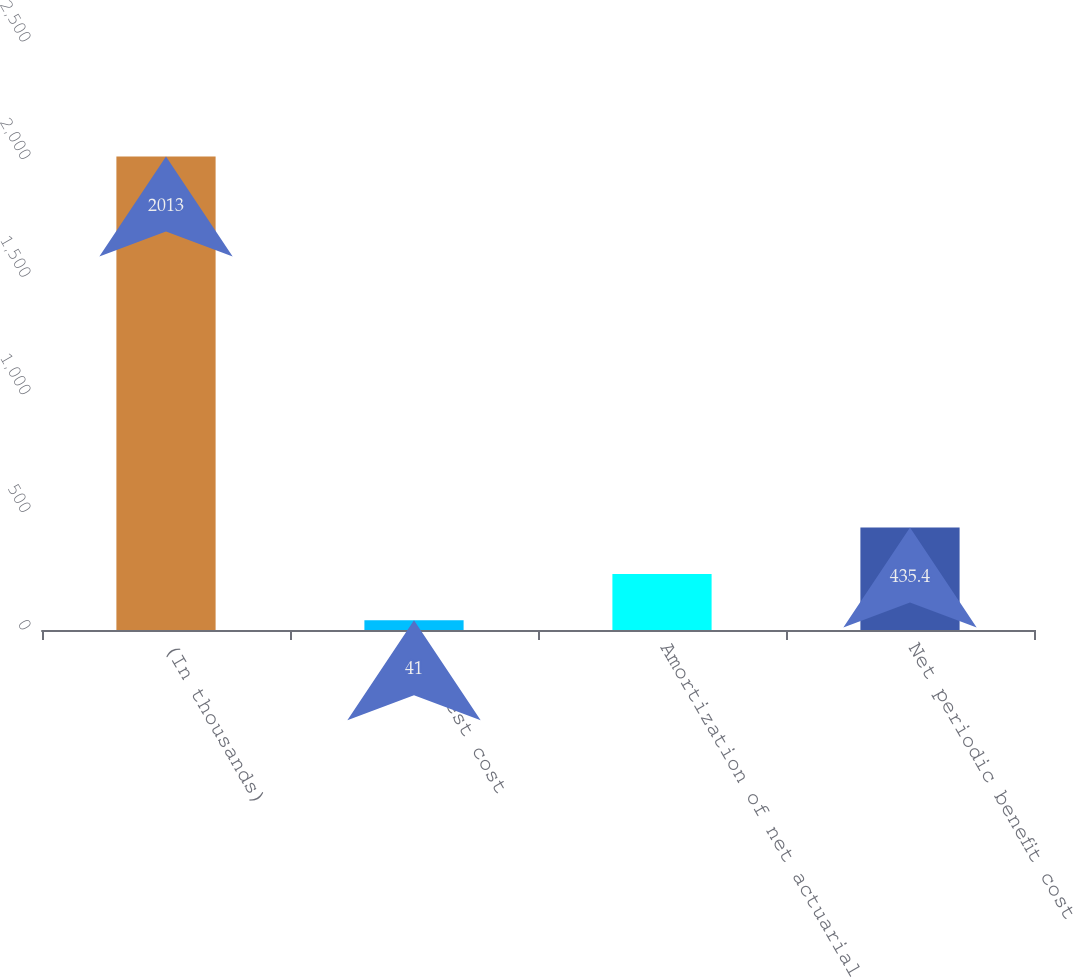Convert chart. <chart><loc_0><loc_0><loc_500><loc_500><bar_chart><fcel>(In thousands)<fcel>Interest cost<fcel>Amortization of net actuarial<fcel>Net periodic benefit cost<nl><fcel>2013<fcel>41<fcel>238.2<fcel>435.4<nl></chart> 